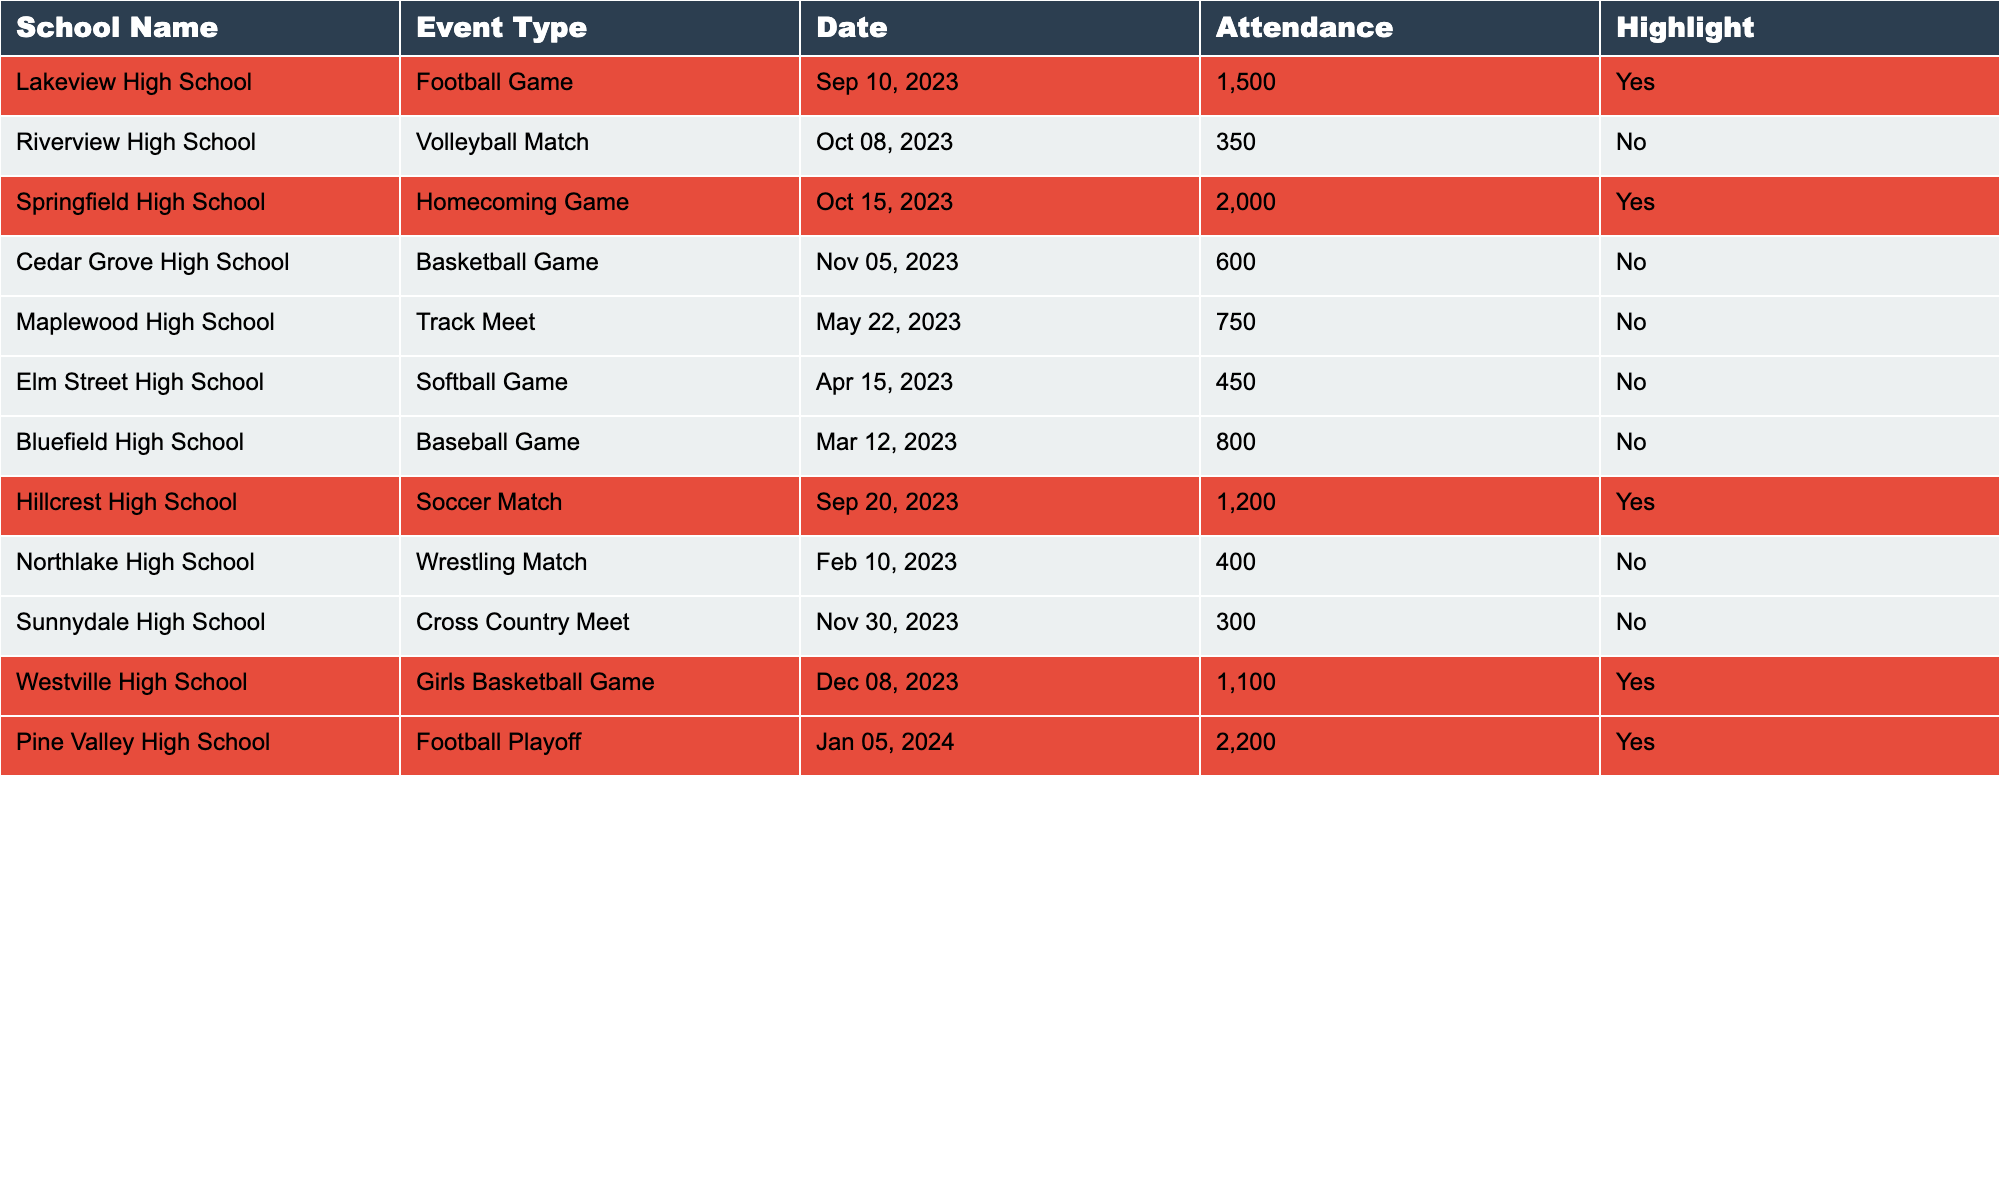What is the highest attendance figure recorded in the table? The table lists several attendance numbers, and by scanning through the values, the highest number is 2,200 from the Pine Valley High School Football Playoff.
Answer: 2,200 Which event had the lowest attendance? Checking the attendance figures in the table reveals that the Sunnydale High School Cross Country Meet had the lowest number at 300.
Answer: 300 How many events had an attendance figure over 1,000? To determine this, I check the attendance numbers and find that four events have figures above 1,000: the Springfield Homecoming Game (2,000), Pine Valley Football Playoff (2,200), Hillcrest Soccer Match (1,200), and Westville Girls Basketball Game (1,100).
Answer: 4 Did Cedar Grove High School have any highlighted events? Looking through the column that indicates highlighting, I note that Cedar Grove High School's Basketball Game does not have the highlight marked as 'Yes.'
Answer: No What was the average attendance for all highlighted events? First, I identify the attendance figures for highlighted events: Lakeview Football Game (1,500), Springfield Homecoming Game (2,000), Hillcrest Soccer Match (1,200), Westville Girls Basketball (1,100), and Pine Valley Football Playoff (2,200). Adding these gives 8,000, and then dividing by 5 (the number of highlighted events) results in an average of 1,600.
Answer: 1,600 Which school had the next highest attendance after Pine Valley High School? After identifying that Pine Valley High School had the highest attendance at 2,200, I review the attendance figures and find that the Springfield High School Homecoming Game follows with an attendance of 2,000.
Answer: Springfield High School Were there more football games or basketball games held? I analyze the table, counting that there are three football games (Lakeview, Pine Valley, and two basketball games (Cedar Grove and Westville). Since three is greater than two, football games were held more frequently.
Answer: More football games How many high school events took place in October? By reviewing the dates in the table, I find there were three events in October: a Volleyball Match at Riverview High School (October 8) and a Homecoming Game at Springfield High School (October 15) and no other events in October.
Answer: 2 What percentage of events had attendance figures below 600? First, I note the total number of events, which is 12. Next, I identify that only the Cedar Grove Basketball Game (600), Elm Street Softball Game (450), Bluefield Baseball Game (800), and Sunnydale Cross Country Meet (300) are below 600. Since only one event (Sunnydale) meets the criteria, the percentage is calculated as (1/12) * 100 = 8.33%.
Answer: 8.33% What was the total attendance for all events in November? I find that there were two events in November: Cedar Grove Basketball Game (600) and the Sunnydale Cross Country Meet (300). Adding these yields 900 as the total attendance.
Answer: 900 